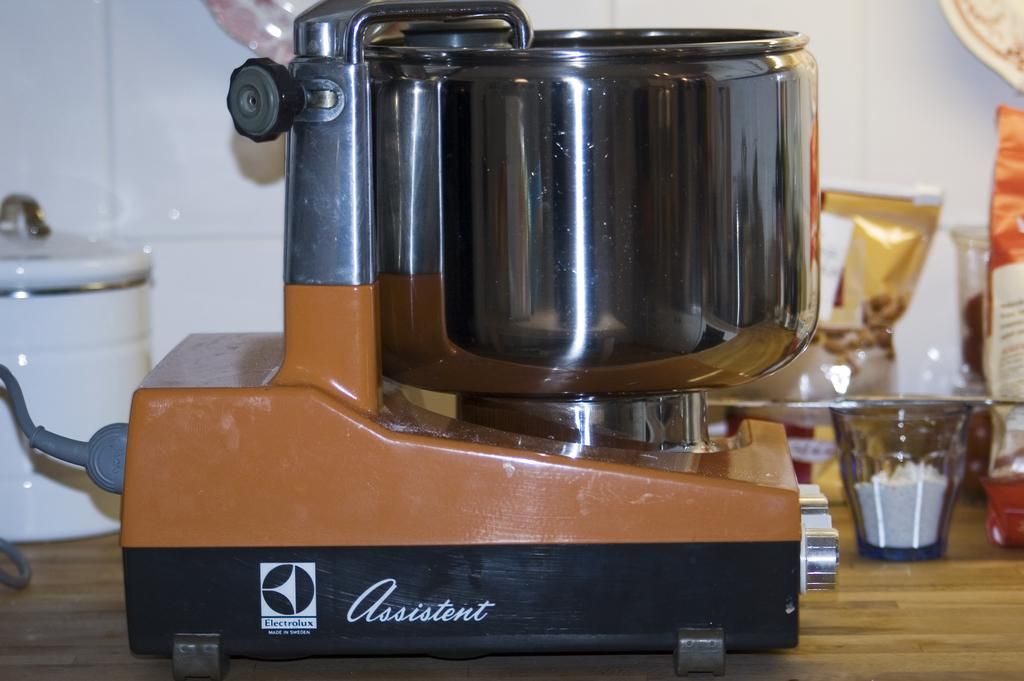<image>
Create a compact narrative representing the image presented. the word assistant is on the brown and black blender 